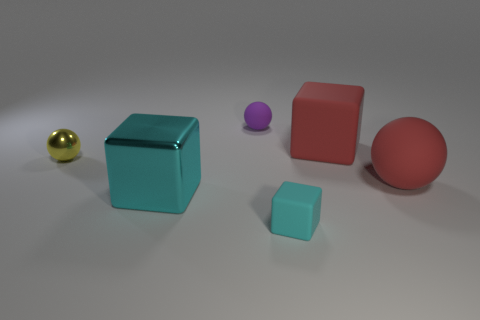There is a red ball that is the same material as the purple sphere; what is its size?
Your answer should be compact. Large. What number of objects are cyan rubber cylinders or metallic blocks?
Provide a succinct answer. 1. What color is the matte block that is in front of the large red ball?
Your answer should be very brief. Cyan. What is the size of the cyan metallic object that is the same shape as the small cyan rubber thing?
Give a very brief answer. Large. How many objects are either things on the right side of the big cyan cube or small matte objects on the left side of the small cyan cube?
Ensure brevity in your answer.  4. There is a ball that is both right of the large cyan thing and in front of the tiny purple thing; what is its size?
Keep it short and to the point. Large. There is a tiny purple rubber object; is it the same shape as the cyan thing that is behind the tiny cyan thing?
Provide a succinct answer. No. What number of things are tiny spheres to the left of the tiny purple matte object or small red shiny cylinders?
Ensure brevity in your answer.  1. Are the small purple object and the small thing in front of the shiny ball made of the same material?
Ensure brevity in your answer.  Yes. The tiny matte object that is on the right side of the tiny matte ball that is behind the shiny block is what shape?
Your answer should be very brief. Cube. 